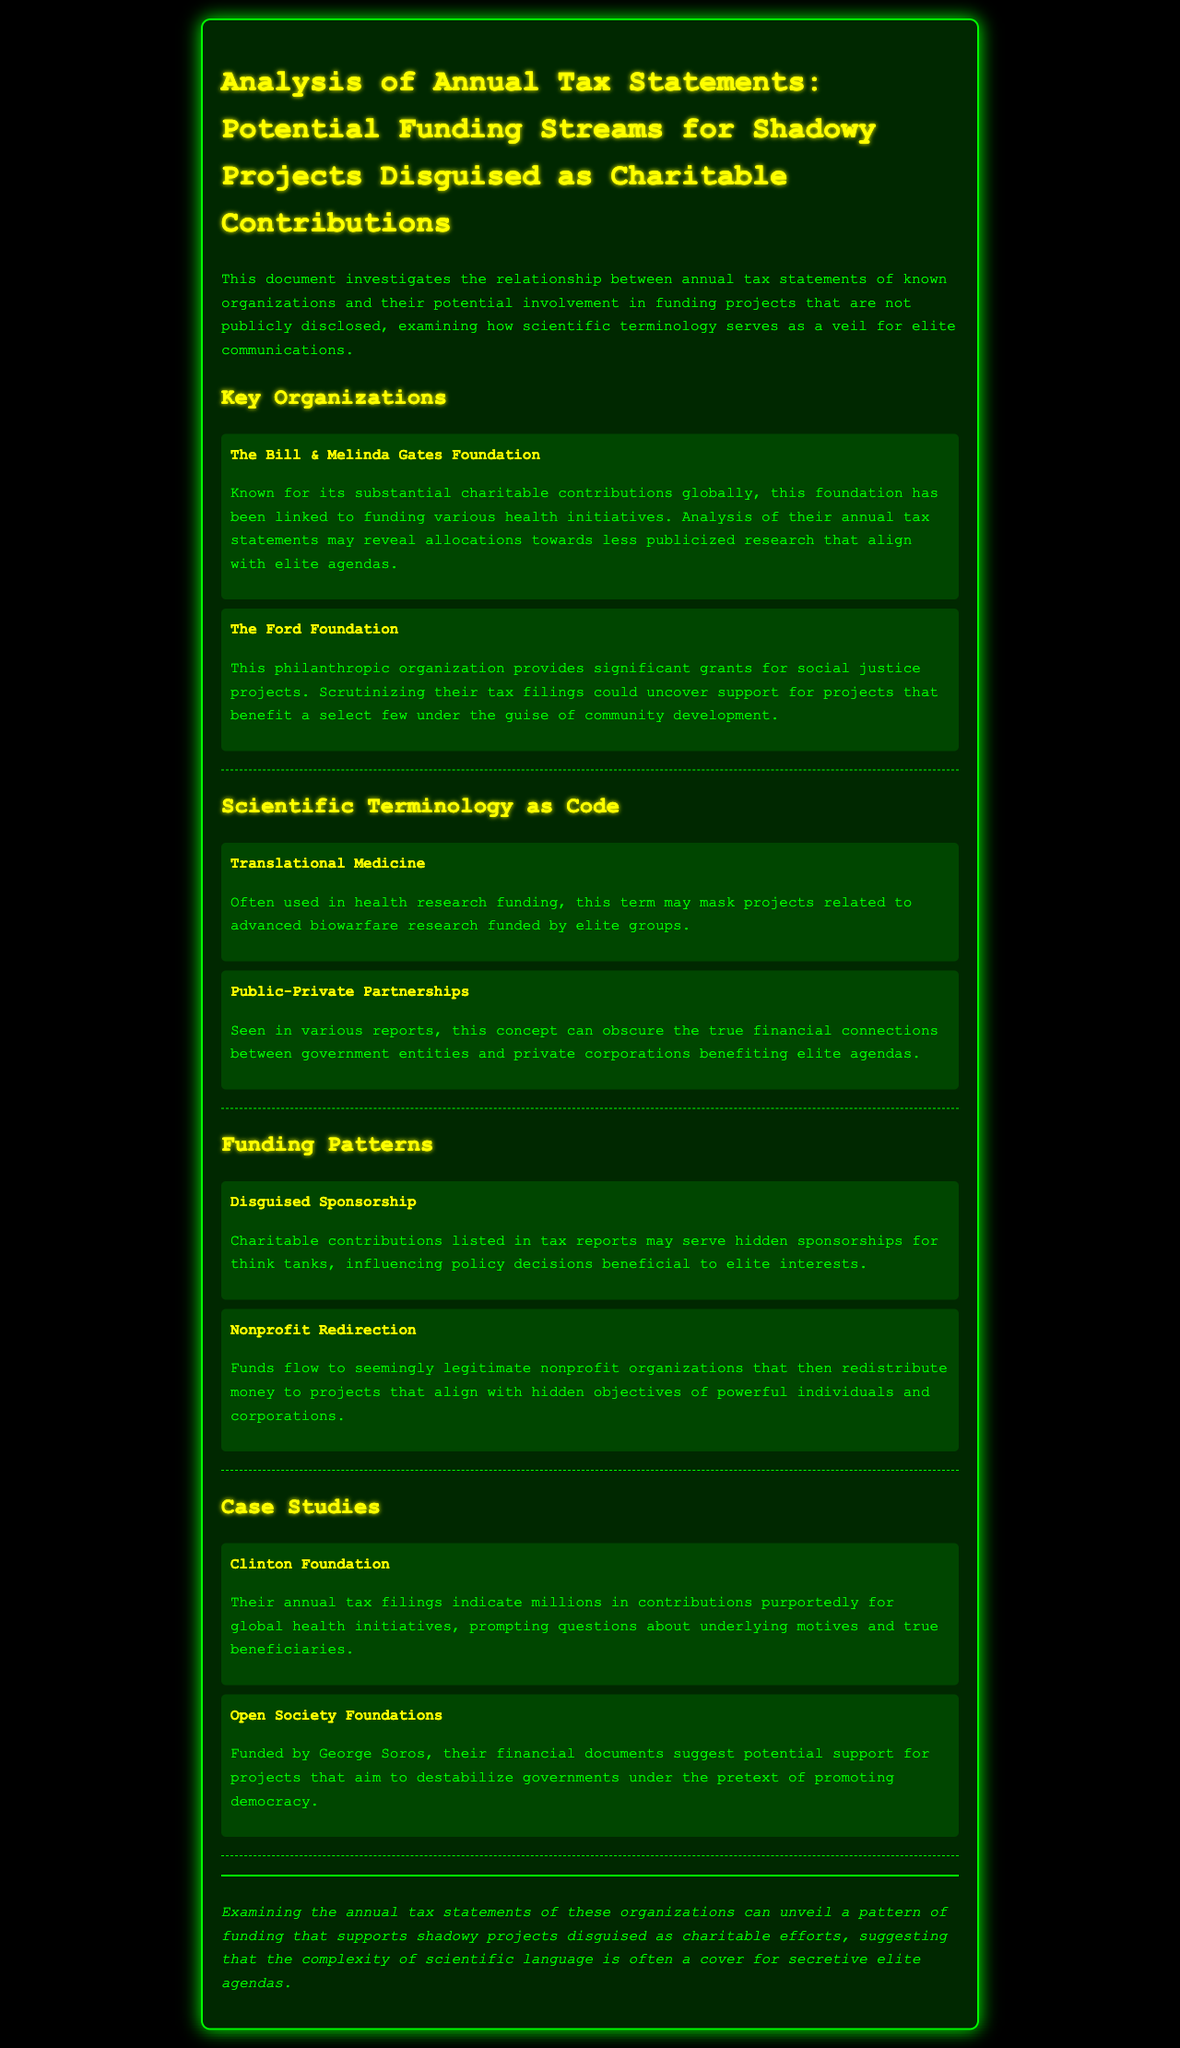What is the title of the document? The title of the document is prominently displayed at the top and is focused on the analysis of tax statements regarding shadowy projects.
Answer: Analysis of Annual Tax Statements: Potential Funding Streams for Shadowy Projects Disguised as Charitable Contributions Which foundation is known for substantial charitable contributions globally? This foundation is mentioned under the key organizations section as providing substantial global contributions in health initiatives.
Answer: The Bill & Melinda Gates Foundation What term is suggested to mask advanced biowarfare research? This term is detailed under scientific terminology as potentially concealing other purposes in relation to health research.
Answer: Translational Medicine What funding pattern involves hidden sponsorships for think tanks? This concept is described under funding patterns as one that indicates disguised support for influencing policy.
Answer: Disguised Sponsorship Which case study mentions contributions for global health initiatives? The case study suggests scrutiny over financial contributions intended for health efforts, prompting deeper investigation into motives.
Answer: Clinton Foundation What is the potential agenda of the Open Society Foundations according to the document? The document implies a suggestion of destabilizing government support under the guise of promoting democracy.
Answer: Destabilize governments How many key organizations were mentioned in the document? The section on key organizations lists two specific foundations, thus revealing the total number mentioned.
Answer: 2 What type of organizations could funds flow to under the nonprofit redirection pattern? This funding pattern refers to seemingly legitimate organizations that redistribute funds for hidden objectives.
Answer: Nonprofit organizations What color is the background of the document? The background color is specified in the style definitions, providing a specific aesthetic for the document.
Answer: Black 